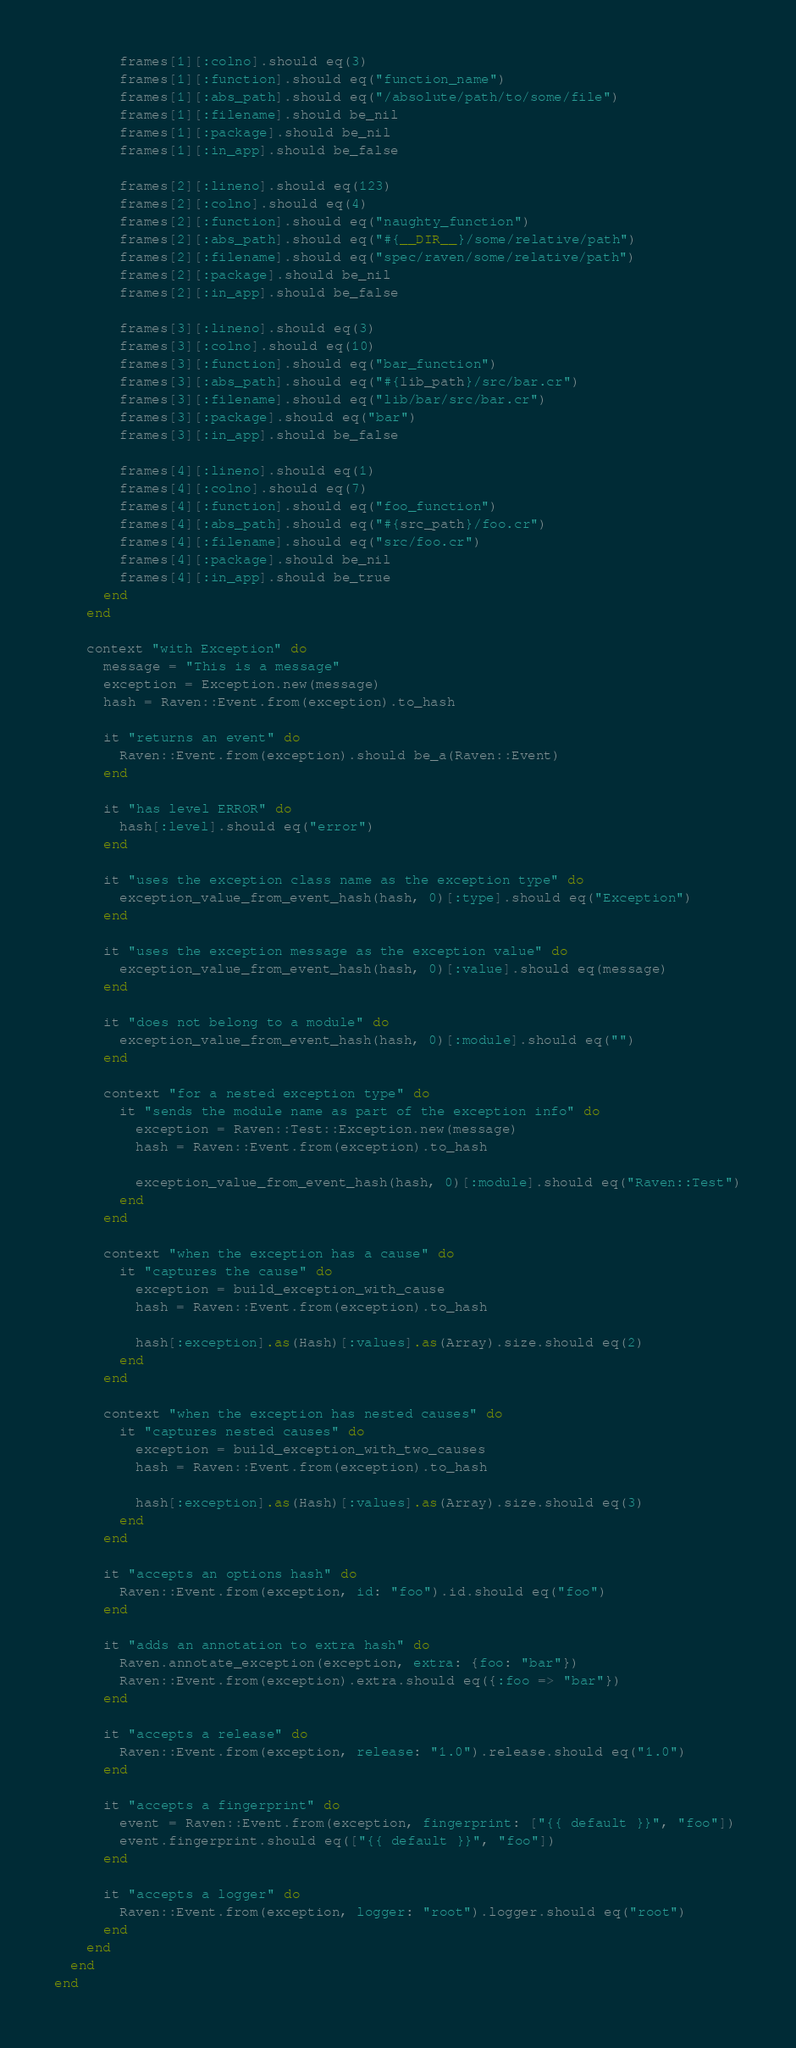Convert code to text. <code><loc_0><loc_0><loc_500><loc_500><_Crystal_>        frames[1][:colno].should eq(3)
        frames[1][:function].should eq("function_name")
        frames[1][:abs_path].should eq("/absolute/path/to/some/file")
        frames[1][:filename].should be_nil
        frames[1][:package].should be_nil
        frames[1][:in_app].should be_false

        frames[2][:lineno].should eq(123)
        frames[2][:colno].should eq(4)
        frames[2][:function].should eq("naughty_function")
        frames[2][:abs_path].should eq("#{__DIR__}/some/relative/path")
        frames[2][:filename].should eq("spec/raven/some/relative/path")
        frames[2][:package].should be_nil
        frames[2][:in_app].should be_false

        frames[3][:lineno].should eq(3)
        frames[3][:colno].should eq(10)
        frames[3][:function].should eq("bar_function")
        frames[3][:abs_path].should eq("#{lib_path}/src/bar.cr")
        frames[3][:filename].should eq("lib/bar/src/bar.cr")
        frames[3][:package].should eq("bar")
        frames[3][:in_app].should be_false

        frames[4][:lineno].should eq(1)
        frames[4][:colno].should eq(7)
        frames[4][:function].should eq("foo_function")
        frames[4][:abs_path].should eq("#{src_path}/foo.cr")
        frames[4][:filename].should eq("src/foo.cr")
        frames[4][:package].should be_nil
        frames[4][:in_app].should be_true
      end
    end

    context "with Exception" do
      message = "This is a message"
      exception = Exception.new(message)
      hash = Raven::Event.from(exception).to_hash

      it "returns an event" do
        Raven::Event.from(exception).should be_a(Raven::Event)
      end

      it "has level ERROR" do
        hash[:level].should eq("error")
      end

      it "uses the exception class name as the exception type" do
        exception_value_from_event_hash(hash, 0)[:type].should eq("Exception")
      end

      it "uses the exception message as the exception value" do
        exception_value_from_event_hash(hash, 0)[:value].should eq(message)
      end

      it "does not belong to a module" do
        exception_value_from_event_hash(hash, 0)[:module].should eq("")
      end

      context "for a nested exception type" do
        it "sends the module name as part of the exception info" do
          exception = Raven::Test::Exception.new(message)
          hash = Raven::Event.from(exception).to_hash

          exception_value_from_event_hash(hash, 0)[:module].should eq("Raven::Test")
        end
      end

      context "when the exception has a cause" do
        it "captures the cause" do
          exception = build_exception_with_cause
          hash = Raven::Event.from(exception).to_hash

          hash[:exception].as(Hash)[:values].as(Array).size.should eq(2)
        end
      end

      context "when the exception has nested causes" do
        it "captures nested causes" do
          exception = build_exception_with_two_causes
          hash = Raven::Event.from(exception).to_hash

          hash[:exception].as(Hash)[:values].as(Array).size.should eq(3)
        end
      end

      it "accepts an options hash" do
        Raven::Event.from(exception, id: "foo").id.should eq("foo")
      end

      it "adds an annotation to extra hash" do
        Raven.annotate_exception(exception, extra: {foo: "bar"})
        Raven::Event.from(exception).extra.should eq({:foo => "bar"})
      end

      it "accepts a release" do
        Raven::Event.from(exception, release: "1.0").release.should eq("1.0")
      end

      it "accepts a fingerprint" do
        event = Raven::Event.from(exception, fingerprint: ["{{ default }}", "foo"])
        event.fingerprint.should eq(["{{ default }}", "foo"])
      end

      it "accepts a logger" do
        Raven::Event.from(exception, logger: "root").logger.should eq("root")
      end
    end
  end
end
</code> 